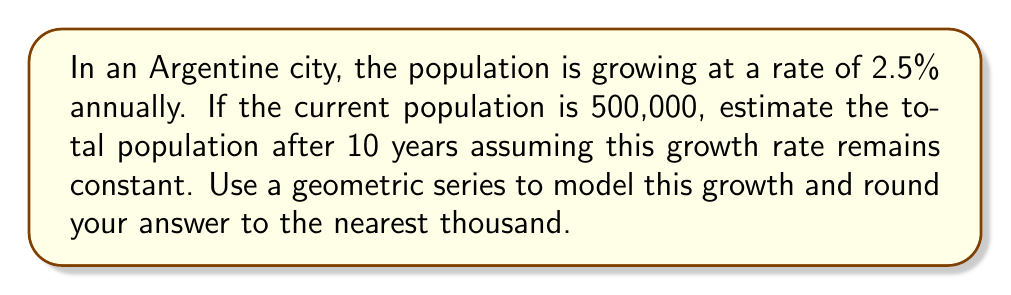Teach me how to tackle this problem. Let's approach this step-by-step using a geometric series:

1) The initial population $a = 500,000$

2) The growth rate is 2.5% per year, so the common ratio $r = 1 + 0.025 = 1.025$

3) We want to find the population after 10 years, so $n = 10$

4) The formula for the nth term of a geometric sequence is:
   $$a_n = a \cdot r^{n-1}$$

5) Substituting our values:
   $$a_{10} = 500,000 \cdot (1.025)^{10-1} = 500,000 \cdot (1.025)^9$$

6) Calculate:
   $$a_{10} = 500,000 \cdot 1.24614 = 623,070$$

7) Rounding to the nearest thousand:
   $$a_{10} \approx 623,000$$

Therefore, the estimated population after 10 years is approximately 623,000.
Answer: 623,000 